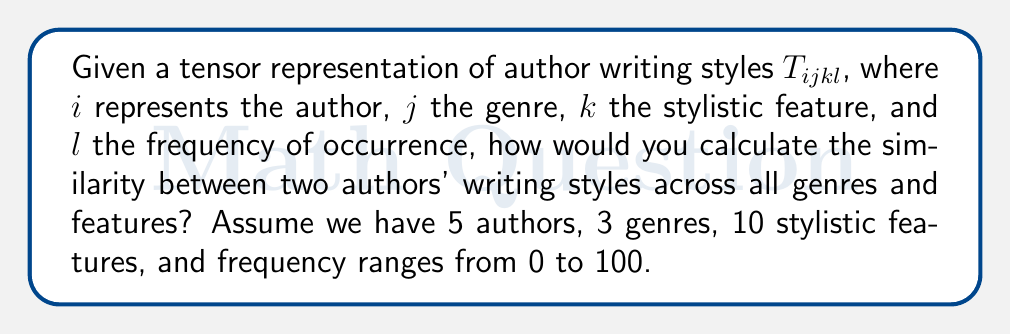Could you help me with this problem? To calculate the similarity between two authors' writing styles, we can use the Frobenius norm of the difference between their tensor slices. Here's a step-by-step approach:

1. Extract the tensor slices for the two authors we want to compare. Let's say we're comparing authors 1 and 2:
   $$A_1 = T_{1jkl}, A_2 = T_{2jkl}$$

2. Calculate the difference tensor:
   $$D_{jkl} = A_{1jkl} - A_{2jkl}$$

3. Compute the Frobenius norm of the difference tensor:
   $$\text{Similarity} = \left\|D\right\|_F = \sqrt{\sum_{j=1}^3 \sum_{k=1}^{10} \sum_{l=0}^{100} D_{jkl}^2}$$

4. Normalize the similarity score:
   $$\text{Normalized Similarity} = 1 - \frac{\text{Similarity}}{\sqrt{3 \cdot 10 \cdot 101 \cdot 100^2}}$$

   The denominator represents the maximum possible difference (all elements being 100 for one author and 0 for the other).

5. The resulting normalized similarity score will be between 0 and 1, where 1 indicates identical writing styles and 0 indicates completely different styles.

This method allows us to compare authors' writing styles across all genres and stylistic features, providing a comprehensive similarity measure that an agent could use to identify authors with similar styles or to diversify their portfolio of represented writers.
Answer: $$1 - \frac{\sqrt{\sum_{j=1}^3 \sum_{k=1}^{10} \sum_{l=0}^{100} (T_{1jkl} - T_{2jkl})^2}}{\sqrt{3 \cdot 10 \cdot 101 \cdot 100^2}}$$ 